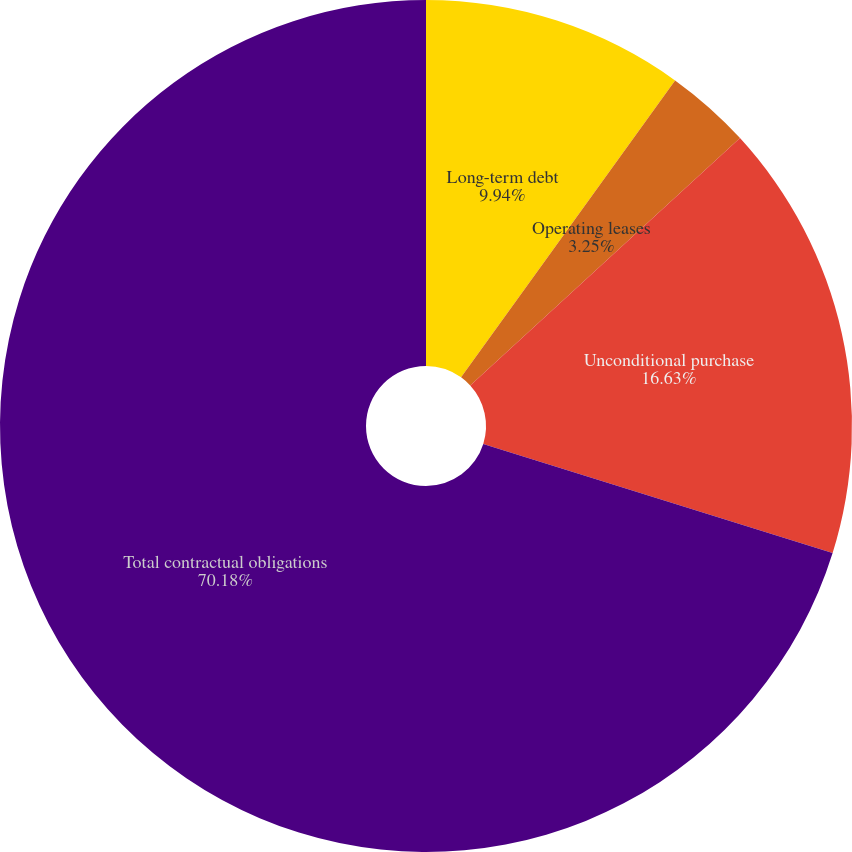Convert chart to OTSL. <chart><loc_0><loc_0><loc_500><loc_500><pie_chart><fcel>Long-term debt<fcel>Operating leases<fcel>Unconditional purchase<fcel>Total contractual obligations<nl><fcel>9.94%<fcel>3.25%<fcel>16.63%<fcel>70.18%<nl></chart> 